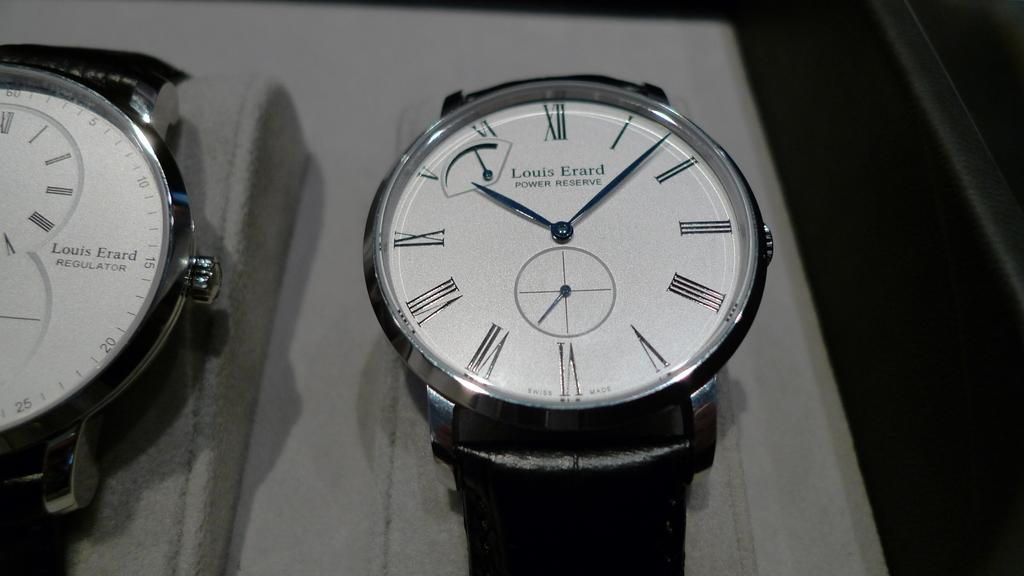<image>
Share a concise interpretation of the image provided. A Louis Erard power reserve watch sits next to another watch. 